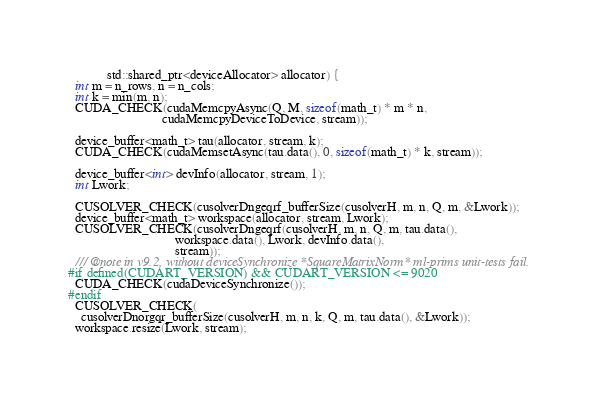Convert code to text. <code><loc_0><loc_0><loc_500><loc_500><_Cuda_>            std::shared_ptr<deviceAllocator> allocator) {
  int m = n_rows, n = n_cols;
  int k = min(m, n);
  CUDA_CHECK(cudaMemcpyAsync(Q, M, sizeof(math_t) * m * n,
                             cudaMemcpyDeviceToDevice, stream));

  device_buffer<math_t> tau(allocator, stream, k);
  CUDA_CHECK(cudaMemsetAsync(tau.data(), 0, sizeof(math_t) * k, stream));

  device_buffer<int> devInfo(allocator, stream, 1);
  int Lwork;

  CUSOLVER_CHECK(cusolverDngeqrf_bufferSize(cusolverH, m, n, Q, m, &Lwork));
  device_buffer<math_t> workspace(allocator, stream, Lwork);
  CUSOLVER_CHECK(cusolverDngeqrf(cusolverH, m, n, Q, m, tau.data(),
                                 workspace.data(), Lwork, devInfo.data(),
                                 stream));
  /// @note in v9.2, without deviceSynchronize *SquareMatrixNorm* ml-prims unit-tests fail.
#if defined(CUDART_VERSION) && CUDART_VERSION <= 9020
  CUDA_CHECK(cudaDeviceSynchronize());
#endif
  CUSOLVER_CHECK(
    cusolverDnorgqr_bufferSize(cusolverH, m, n, k, Q, m, tau.data(), &Lwork));
  workspace.resize(Lwork, stream);</code> 